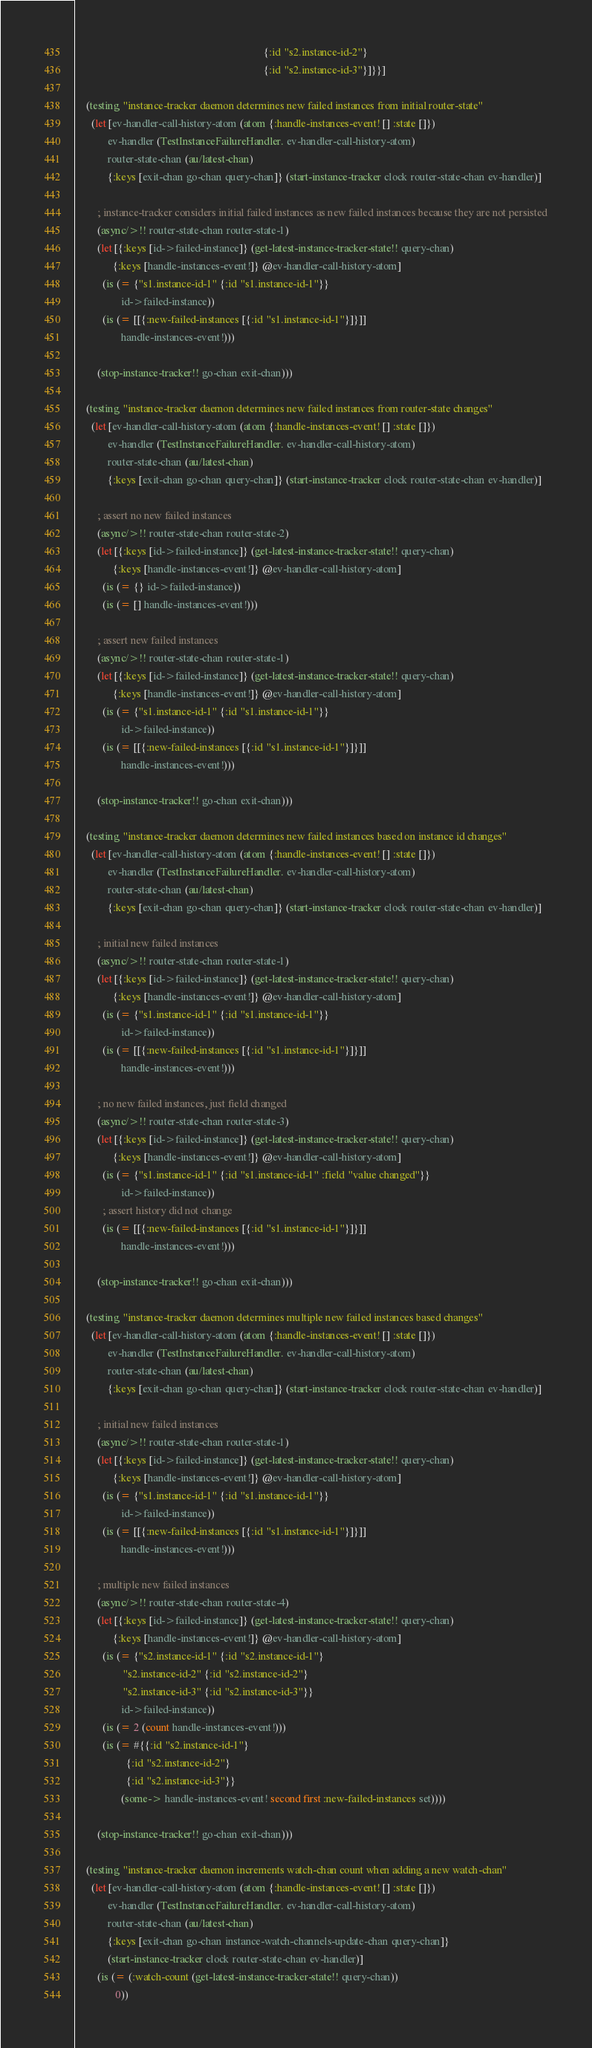Convert code to text. <code><loc_0><loc_0><loc_500><loc_500><_Clojure_>                                                                       {:id "s2.instance-id-2"}
                                                                       {:id "s2.instance-id-3"}]}}]

    (testing "instance-tracker daemon determines new failed instances from initial router-state"
      (let [ev-handler-call-history-atom (atom {:handle-instances-event! [] :state []})
            ev-handler (TestInstanceFailureHandler. ev-handler-call-history-atom)
            router-state-chan (au/latest-chan)
            {:keys [exit-chan go-chan query-chan]} (start-instance-tracker clock router-state-chan ev-handler)]

        ; instance-tracker considers initial failed instances as new failed instances because they are not persisted
        (async/>!! router-state-chan router-state-1)
        (let [{:keys [id->failed-instance]} (get-latest-instance-tracker-state!! query-chan)
              {:keys [handle-instances-event!]} @ev-handler-call-history-atom]
          (is (= {"s1.instance-id-1" {:id "s1.instance-id-1"}}
                 id->failed-instance))
          (is (= [[{:new-failed-instances [{:id "s1.instance-id-1"}]}]]
                 handle-instances-event!)))

        (stop-instance-tracker!! go-chan exit-chan)))

    (testing "instance-tracker daemon determines new failed instances from router-state changes"
      (let [ev-handler-call-history-atom (atom {:handle-instances-event! [] :state []})
            ev-handler (TestInstanceFailureHandler. ev-handler-call-history-atom)
            router-state-chan (au/latest-chan)
            {:keys [exit-chan go-chan query-chan]} (start-instance-tracker clock router-state-chan ev-handler)]

        ; assert no new failed instances
        (async/>!! router-state-chan router-state-2)
        (let [{:keys [id->failed-instance]} (get-latest-instance-tracker-state!! query-chan)
              {:keys [handle-instances-event!]} @ev-handler-call-history-atom]
          (is (= {} id->failed-instance))
          (is (= [] handle-instances-event!)))

        ; assert new failed instances
        (async/>!! router-state-chan router-state-1)
        (let [{:keys [id->failed-instance]} (get-latest-instance-tracker-state!! query-chan)
              {:keys [handle-instances-event!]} @ev-handler-call-history-atom]
          (is (= {"s1.instance-id-1" {:id "s1.instance-id-1"}}
                 id->failed-instance))
          (is (= [[{:new-failed-instances [{:id "s1.instance-id-1"}]}]]
                 handle-instances-event!)))

        (stop-instance-tracker!! go-chan exit-chan)))

    (testing "instance-tracker daemon determines new failed instances based on instance id changes"
      (let [ev-handler-call-history-atom (atom {:handle-instances-event! [] :state []})
            ev-handler (TestInstanceFailureHandler. ev-handler-call-history-atom)
            router-state-chan (au/latest-chan)
            {:keys [exit-chan go-chan query-chan]} (start-instance-tracker clock router-state-chan ev-handler)]

        ; initial new failed instances
        (async/>!! router-state-chan router-state-1)
        (let [{:keys [id->failed-instance]} (get-latest-instance-tracker-state!! query-chan)
              {:keys [handle-instances-event!]} @ev-handler-call-history-atom]
          (is (= {"s1.instance-id-1" {:id "s1.instance-id-1"}}
                 id->failed-instance))
          (is (= [[{:new-failed-instances [{:id "s1.instance-id-1"}]}]]
                 handle-instances-event!)))

        ; no new failed instances, just field changed
        (async/>!! router-state-chan router-state-3)
        (let [{:keys [id->failed-instance]} (get-latest-instance-tracker-state!! query-chan)
              {:keys [handle-instances-event!]} @ev-handler-call-history-atom]
          (is (= {"s1.instance-id-1" {:id "s1.instance-id-1" :field "value changed"}}
                 id->failed-instance))
          ; assert history did not change
          (is (= [[{:new-failed-instances [{:id "s1.instance-id-1"}]}]]
                 handle-instances-event!)))

        (stop-instance-tracker!! go-chan exit-chan)))

    (testing "instance-tracker daemon determines multiple new failed instances based changes"
      (let [ev-handler-call-history-atom (atom {:handle-instances-event! [] :state []})
            ev-handler (TestInstanceFailureHandler. ev-handler-call-history-atom)
            router-state-chan (au/latest-chan)
            {:keys [exit-chan go-chan query-chan]} (start-instance-tracker clock router-state-chan ev-handler)]

        ; initial new failed instances
        (async/>!! router-state-chan router-state-1)
        (let [{:keys [id->failed-instance]} (get-latest-instance-tracker-state!! query-chan)
              {:keys [handle-instances-event!]} @ev-handler-call-history-atom]
          (is (= {"s1.instance-id-1" {:id "s1.instance-id-1"}}
                 id->failed-instance))
          (is (= [[{:new-failed-instances [{:id "s1.instance-id-1"}]}]]
                 handle-instances-event!)))

        ; multiple new failed instances
        (async/>!! router-state-chan router-state-4)
        (let [{:keys [id->failed-instance]} (get-latest-instance-tracker-state!! query-chan)
              {:keys [handle-instances-event!]} @ev-handler-call-history-atom]
          (is (= {"s2.instance-id-1" {:id "s2.instance-id-1"}
                  "s2.instance-id-2" {:id "s2.instance-id-2"}
                  "s2.instance-id-3" {:id "s2.instance-id-3"}}
                 id->failed-instance))
          (is (= 2 (count handle-instances-event!)))
          (is (= #{{:id "s2.instance-id-1"}
                   {:id "s2.instance-id-2"}
                   {:id "s2.instance-id-3"}}
                 (some-> handle-instances-event! second first :new-failed-instances set))))

        (stop-instance-tracker!! go-chan exit-chan)))

    (testing "instance-tracker daemon increments watch-chan count when adding a new watch-chan"
      (let [ev-handler-call-history-atom (atom {:handle-instances-event! [] :state []})
            ev-handler (TestInstanceFailureHandler. ev-handler-call-history-atom)
            router-state-chan (au/latest-chan)
            {:keys [exit-chan go-chan instance-watch-channels-update-chan query-chan]}
            (start-instance-tracker clock router-state-chan ev-handler)]
        (is (= (:watch-count (get-latest-instance-tracker-state!! query-chan))
               0))</code> 